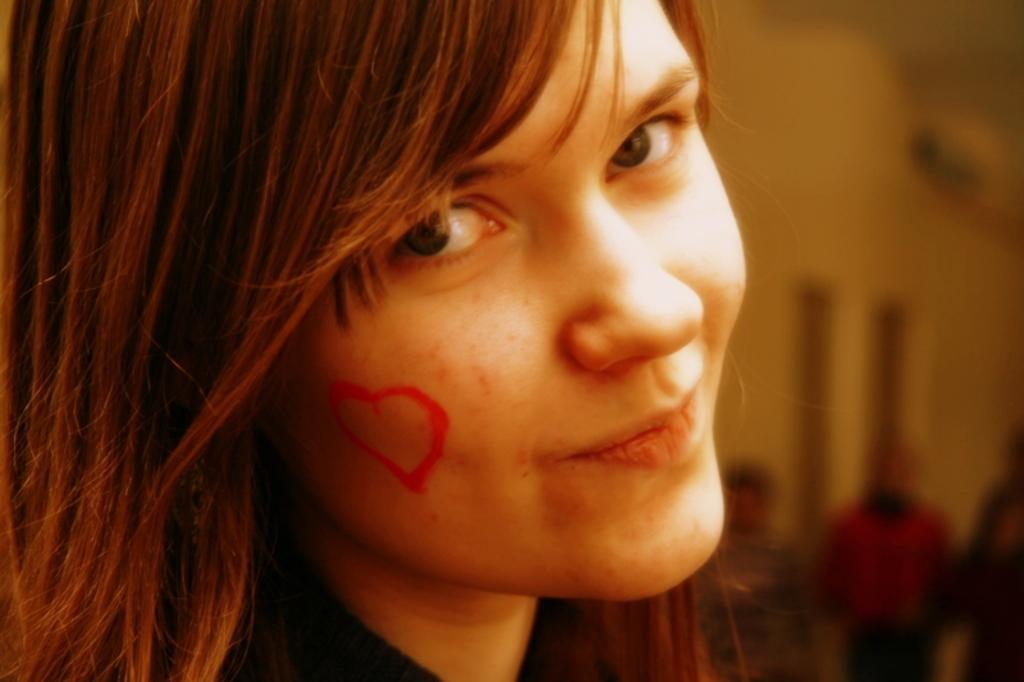Describe this image in one or two sentences. In the image there is a woman and there is a heart shaped mark on her cheek. 